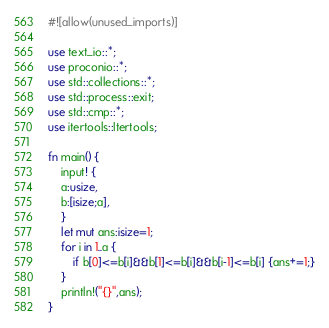Convert code to text. <code><loc_0><loc_0><loc_500><loc_500><_Rust_>#![allow(unused_imports)]

use text_io::*;
use proconio::*;
use std::collections::*;
use std::process::exit;
use std::cmp::*;
use itertools::Itertools;

fn main() {
    input! {
    a:usize,
    b:[isize;a],
    }
    let mut ans:isize=1;
    for i in 1..a {
        if b[0]<=b[i]&&b[1]<=b[i]&&b[i-1]<=b[i] {ans+=1;}
    }
    println!("{}",ans);
}</code> 